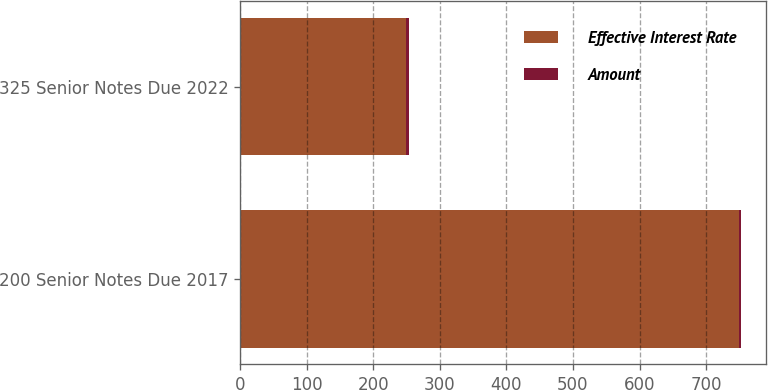<chart> <loc_0><loc_0><loc_500><loc_500><stacked_bar_chart><ecel><fcel>200 Senior Notes Due 2017<fcel>325 Senior Notes Due 2022<nl><fcel>Effective Interest Rate<fcel>750<fcel>250<nl><fcel>Amount<fcel>2.25<fcel>3.43<nl></chart> 